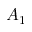Convert formula to latex. <formula><loc_0><loc_0><loc_500><loc_500>A _ { 1 }</formula> 